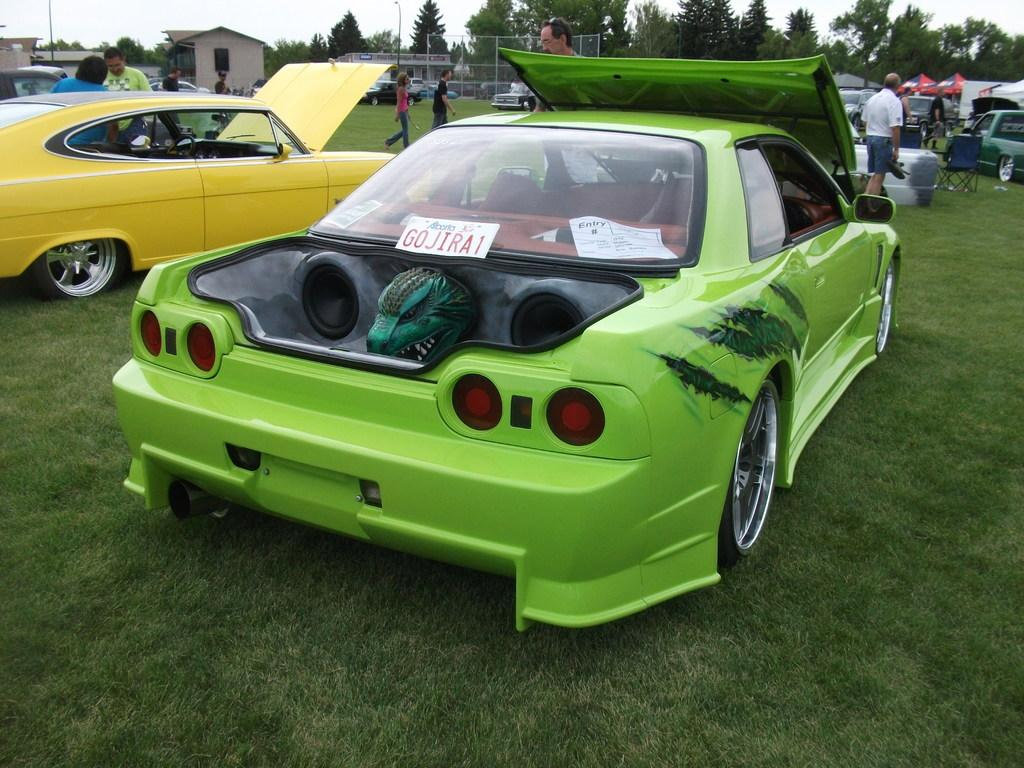<image>
Offer a succinct explanation of the picture presented. the word Go on the back of a car 